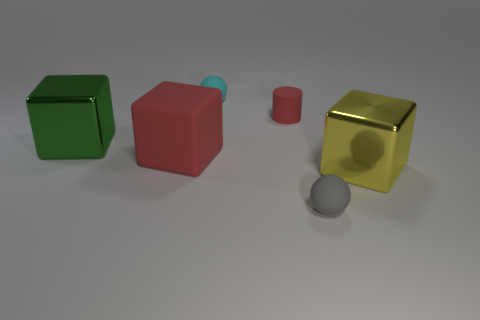There is a rubber thing that is the same color as the matte block; what size is it?
Provide a succinct answer. Small. There is a sphere that is behind the large green block; what color is it?
Your response must be concise. Cyan. Do the gray rubber ball and the yellow cube have the same size?
Ensure brevity in your answer.  No. The big thing that is to the right of the small gray object that is left of the yellow metal object is made of what material?
Make the answer very short. Metal. How many large matte blocks have the same color as the tiny rubber cylinder?
Give a very brief answer. 1. Is the number of red rubber things in front of the large yellow metallic block less than the number of yellow blocks?
Your answer should be very brief. Yes. What is the color of the shiny object in front of the big shiny object behind the large yellow metallic cube?
Your answer should be compact. Yellow. What is the size of the matte sphere that is behind the metal object right of the small sphere left of the tiny gray rubber ball?
Give a very brief answer. Small. Is the number of tiny balls behind the tiny red cylinder less than the number of small things behind the large yellow metallic cube?
Your answer should be very brief. Yes. What number of large green cubes are made of the same material as the red cylinder?
Your answer should be very brief. 0. 